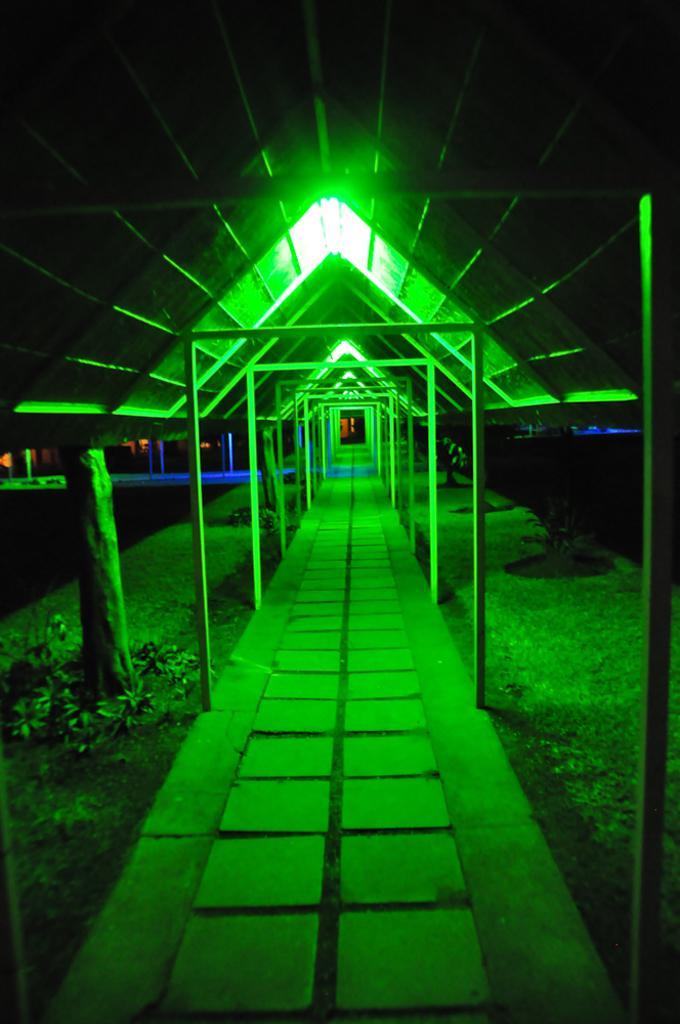Can you describe this image briefly? At the top there are lights to the shed. At the bottom it is the way. 